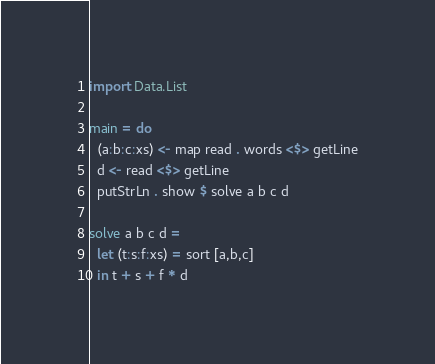<code> <loc_0><loc_0><loc_500><loc_500><_Haskell_>import Data.List

main = do 
  (a:b:c:xs) <- map read . words <$> getLine
  d <- read <$> getLine
  putStrLn . show $ solve a b c d

solve a b c d = 
  let (t:s:f:xs) = sort [a,b,c]
  in t + s + f * d</code> 